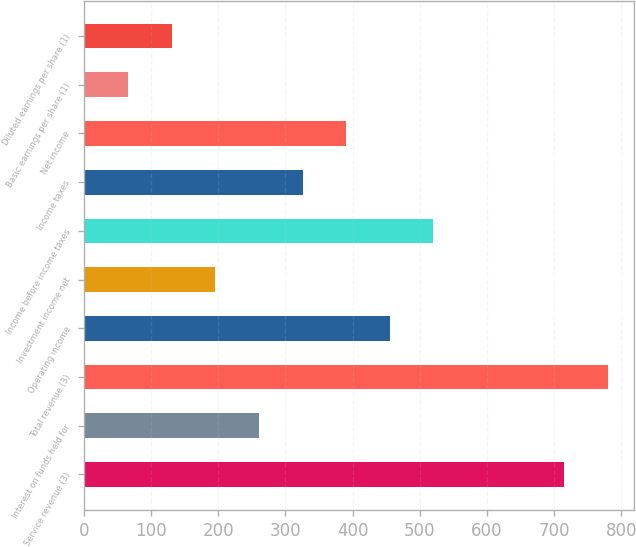<chart> <loc_0><loc_0><loc_500><loc_500><bar_chart><fcel>Service revenue (3)<fcel>Interest on funds held for<fcel>Total revenue (3)<fcel>Operating income<fcel>Investment income net<fcel>Income before income taxes<fcel>Income taxes<fcel>Net income<fcel>Basic earnings per share (1)<fcel>Diluted earnings per share (1)<nl><fcel>715.38<fcel>260.36<fcel>780.38<fcel>455.38<fcel>195.35<fcel>520.38<fcel>325.37<fcel>390.38<fcel>65.35<fcel>130.35<nl></chart> 